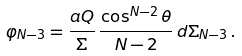<formula> <loc_0><loc_0><loc_500><loc_500>\varphi _ { N - 3 } = \frac { a Q } { \Sigma } \, \frac { \cos ^ { N - 2 } \theta } { N - 2 } \, d \Sigma _ { N - 3 } \, .</formula> 